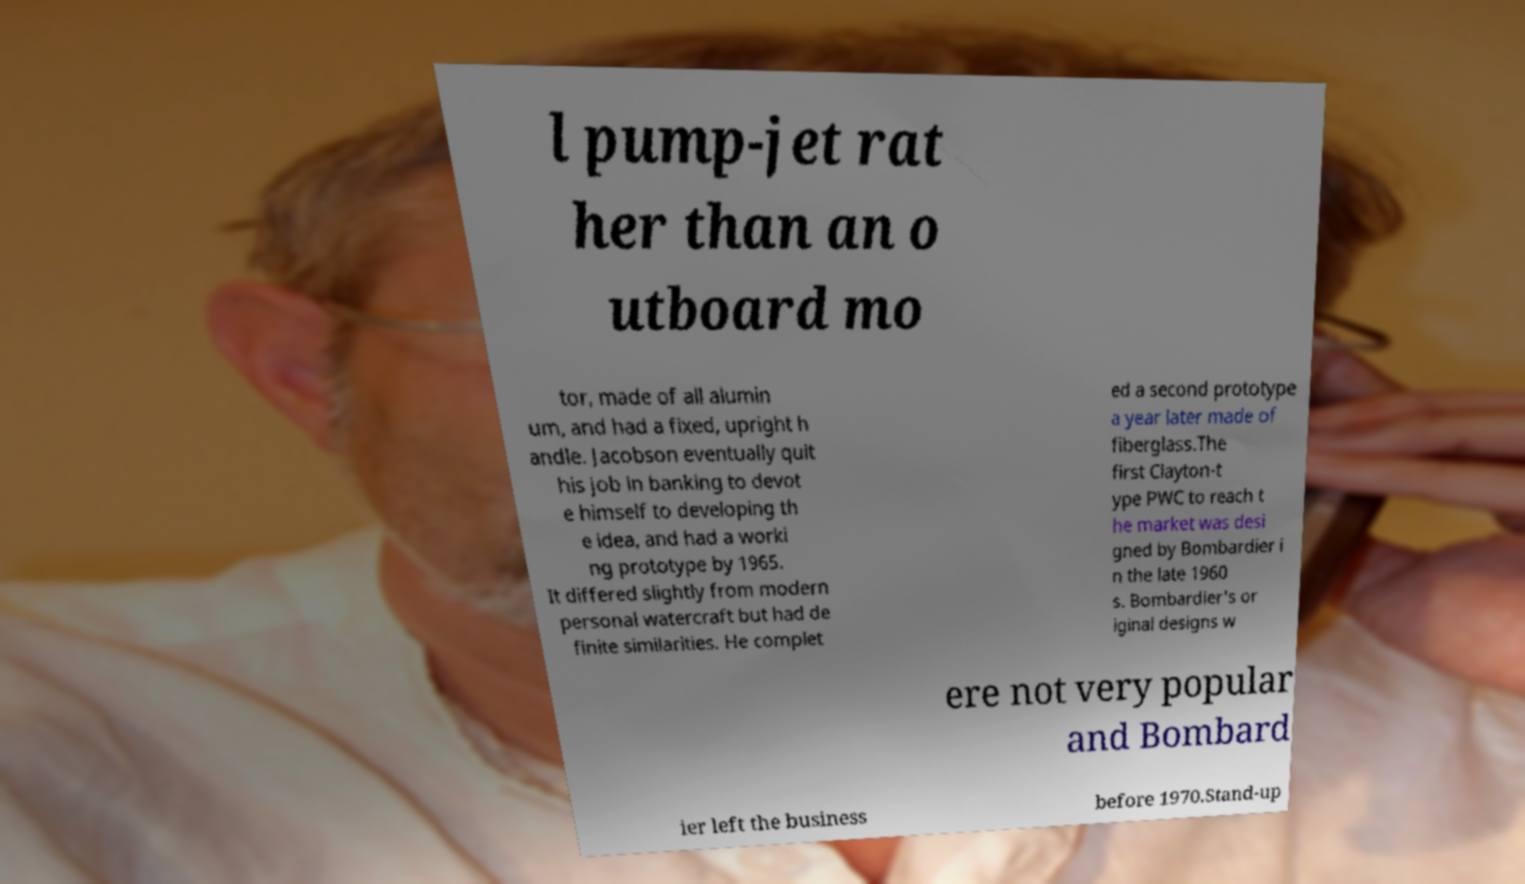What messages or text are displayed in this image? I need them in a readable, typed format. l pump-jet rat her than an o utboard mo tor, made of all alumin um, and had a fixed, upright h andle. Jacobson eventually quit his job in banking to devot e himself to developing th e idea, and had a worki ng prototype by 1965. It differed slightly from modern personal watercraft but had de finite similarities. He complet ed a second prototype a year later made of fiberglass.The first Clayton-t ype PWC to reach t he market was desi gned by Bombardier i n the late 1960 s. Bombardier's or iginal designs w ere not very popular and Bombard ier left the business before 1970.Stand-up 